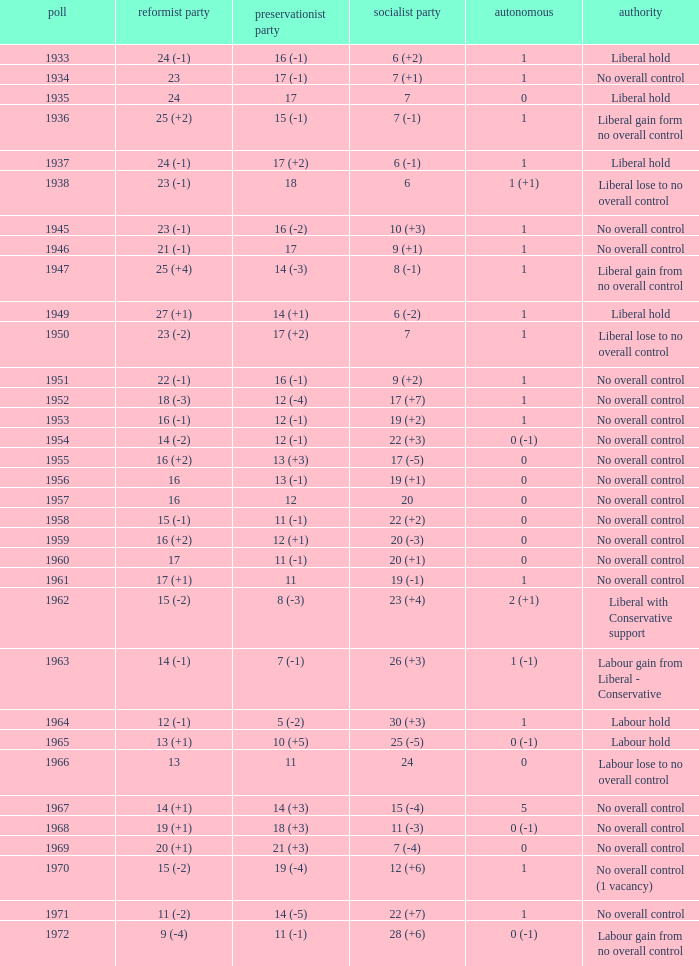What was the Liberal Party result from the election having a Conservative Party result of 16 (-1) and Labour of 6 (+2)? 24 (-1). 